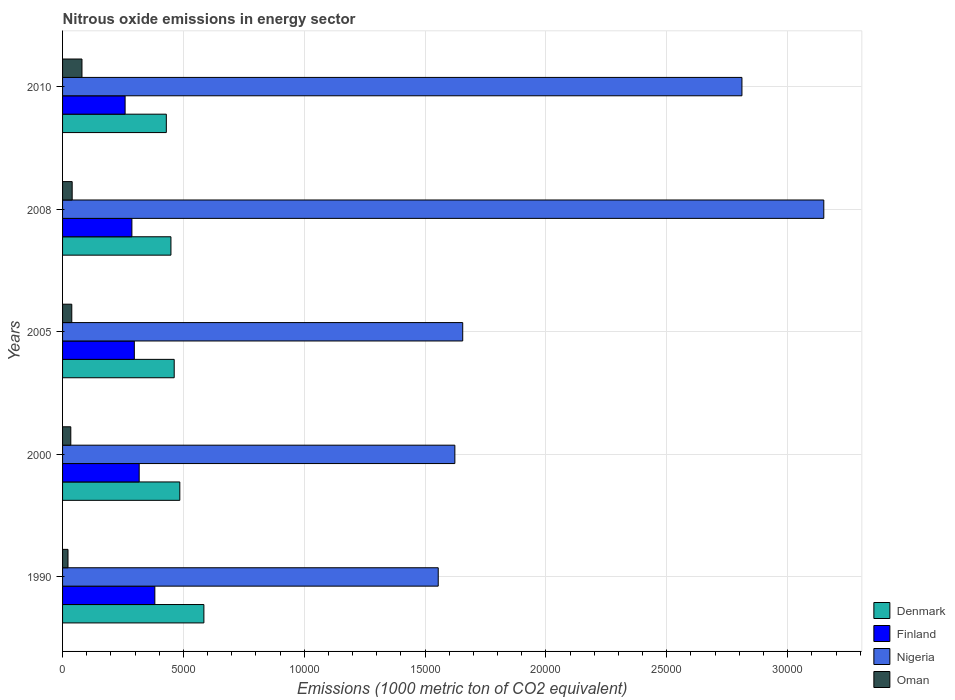How many groups of bars are there?
Keep it short and to the point. 5. Are the number of bars per tick equal to the number of legend labels?
Your answer should be compact. Yes. How many bars are there on the 2nd tick from the top?
Offer a very short reply. 4. In how many cases, is the number of bars for a given year not equal to the number of legend labels?
Your answer should be very brief. 0. What is the amount of nitrous oxide emitted in Denmark in 2000?
Provide a succinct answer. 4850.8. Across all years, what is the maximum amount of nitrous oxide emitted in Finland?
Offer a terse response. 3817.9. Across all years, what is the minimum amount of nitrous oxide emitted in Finland?
Offer a very short reply. 2587.6. In which year was the amount of nitrous oxide emitted in Denmark minimum?
Provide a short and direct response. 2010. What is the total amount of nitrous oxide emitted in Nigeria in the graph?
Ensure brevity in your answer.  1.08e+05. What is the difference between the amount of nitrous oxide emitted in Oman in 2008 and that in 2010?
Your answer should be compact. -405.6. What is the difference between the amount of nitrous oxide emitted in Finland in 2005 and the amount of nitrous oxide emitted in Oman in 2000?
Your answer should be compact. 2628.6. What is the average amount of nitrous oxide emitted in Denmark per year?
Your answer should be very brief. 4818.62. In the year 2008, what is the difference between the amount of nitrous oxide emitted in Denmark and amount of nitrous oxide emitted in Nigeria?
Your response must be concise. -2.70e+04. What is the ratio of the amount of nitrous oxide emitted in Finland in 1990 to that in 2000?
Provide a succinct answer. 1.2. Is the amount of nitrous oxide emitted in Oman in 1990 less than that in 2000?
Your response must be concise. Yes. Is the difference between the amount of nitrous oxide emitted in Denmark in 1990 and 2000 greater than the difference between the amount of nitrous oxide emitted in Nigeria in 1990 and 2000?
Offer a terse response. Yes. What is the difference between the highest and the second highest amount of nitrous oxide emitted in Finland?
Provide a succinct answer. 648. What is the difference between the highest and the lowest amount of nitrous oxide emitted in Finland?
Ensure brevity in your answer.  1230.3. In how many years, is the amount of nitrous oxide emitted in Oman greater than the average amount of nitrous oxide emitted in Oman taken over all years?
Offer a terse response. 1. Is the sum of the amount of nitrous oxide emitted in Oman in 1990 and 2005 greater than the maximum amount of nitrous oxide emitted in Nigeria across all years?
Your answer should be very brief. No. What does the 1st bar from the top in 2005 represents?
Make the answer very short. Oman. What does the 4th bar from the bottom in 2010 represents?
Provide a succinct answer. Oman. How many bars are there?
Ensure brevity in your answer.  20. How many years are there in the graph?
Provide a short and direct response. 5. Does the graph contain grids?
Ensure brevity in your answer.  Yes. How many legend labels are there?
Your answer should be very brief. 4. What is the title of the graph?
Your response must be concise. Nitrous oxide emissions in energy sector. Does "Marshall Islands" appear as one of the legend labels in the graph?
Offer a very short reply. No. What is the label or title of the X-axis?
Your answer should be compact. Emissions (1000 metric ton of CO2 equivalent). What is the Emissions (1000 metric ton of CO2 equivalent) in Denmark in 1990?
Make the answer very short. 5847.4. What is the Emissions (1000 metric ton of CO2 equivalent) of Finland in 1990?
Offer a very short reply. 3817.9. What is the Emissions (1000 metric ton of CO2 equivalent) of Nigeria in 1990?
Provide a short and direct response. 1.55e+04. What is the Emissions (1000 metric ton of CO2 equivalent) of Oman in 1990?
Your answer should be very brief. 225. What is the Emissions (1000 metric ton of CO2 equivalent) of Denmark in 2000?
Your answer should be compact. 4850.8. What is the Emissions (1000 metric ton of CO2 equivalent) in Finland in 2000?
Your answer should be compact. 3169.9. What is the Emissions (1000 metric ton of CO2 equivalent) of Nigeria in 2000?
Your answer should be very brief. 1.62e+04. What is the Emissions (1000 metric ton of CO2 equivalent) of Oman in 2000?
Provide a short and direct response. 340.4. What is the Emissions (1000 metric ton of CO2 equivalent) in Denmark in 2005?
Your response must be concise. 4618.6. What is the Emissions (1000 metric ton of CO2 equivalent) of Finland in 2005?
Offer a terse response. 2969. What is the Emissions (1000 metric ton of CO2 equivalent) of Nigeria in 2005?
Keep it short and to the point. 1.66e+04. What is the Emissions (1000 metric ton of CO2 equivalent) in Oman in 2005?
Your answer should be compact. 381.4. What is the Emissions (1000 metric ton of CO2 equivalent) of Denmark in 2008?
Your response must be concise. 4483.4. What is the Emissions (1000 metric ton of CO2 equivalent) of Finland in 2008?
Offer a very short reply. 2868. What is the Emissions (1000 metric ton of CO2 equivalent) in Nigeria in 2008?
Provide a short and direct response. 3.15e+04. What is the Emissions (1000 metric ton of CO2 equivalent) in Oman in 2008?
Your response must be concise. 397.4. What is the Emissions (1000 metric ton of CO2 equivalent) in Denmark in 2010?
Provide a short and direct response. 4292.9. What is the Emissions (1000 metric ton of CO2 equivalent) of Finland in 2010?
Your answer should be very brief. 2587.6. What is the Emissions (1000 metric ton of CO2 equivalent) in Nigeria in 2010?
Give a very brief answer. 2.81e+04. What is the Emissions (1000 metric ton of CO2 equivalent) in Oman in 2010?
Offer a terse response. 803. Across all years, what is the maximum Emissions (1000 metric ton of CO2 equivalent) of Denmark?
Give a very brief answer. 5847.4. Across all years, what is the maximum Emissions (1000 metric ton of CO2 equivalent) in Finland?
Ensure brevity in your answer.  3817.9. Across all years, what is the maximum Emissions (1000 metric ton of CO2 equivalent) in Nigeria?
Provide a succinct answer. 3.15e+04. Across all years, what is the maximum Emissions (1000 metric ton of CO2 equivalent) in Oman?
Provide a succinct answer. 803. Across all years, what is the minimum Emissions (1000 metric ton of CO2 equivalent) in Denmark?
Your answer should be very brief. 4292.9. Across all years, what is the minimum Emissions (1000 metric ton of CO2 equivalent) of Finland?
Ensure brevity in your answer.  2587.6. Across all years, what is the minimum Emissions (1000 metric ton of CO2 equivalent) in Nigeria?
Offer a terse response. 1.55e+04. Across all years, what is the minimum Emissions (1000 metric ton of CO2 equivalent) of Oman?
Your answer should be very brief. 225. What is the total Emissions (1000 metric ton of CO2 equivalent) of Denmark in the graph?
Provide a short and direct response. 2.41e+04. What is the total Emissions (1000 metric ton of CO2 equivalent) in Finland in the graph?
Make the answer very short. 1.54e+04. What is the total Emissions (1000 metric ton of CO2 equivalent) in Nigeria in the graph?
Provide a succinct answer. 1.08e+05. What is the total Emissions (1000 metric ton of CO2 equivalent) of Oman in the graph?
Keep it short and to the point. 2147.2. What is the difference between the Emissions (1000 metric ton of CO2 equivalent) of Denmark in 1990 and that in 2000?
Your response must be concise. 996.6. What is the difference between the Emissions (1000 metric ton of CO2 equivalent) in Finland in 1990 and that in 2000?
Keep it short and to the point. 648. What is the difference between the Emissions (1000 metric ton of CO2 equivalent) of Nigeria in 1990 and that in 2000?
Keep it short and to the point. -688.1. What is the difference between the Emissions (1000 metric ton of CO2 equivalent) in Oman in 1990 and that in 2000?
Give a very brief answer. -115.4. What is the difference between the Emissions (1000 metric ton of CO2 equivalent) of Denmark in 1990 and that in 2005?
Provide a short and direct response. 1228.8. What is the difference between the Emissions (1000 metric ton of CO2 equivalent) of Finland in 1990 and that in 2005?
Your response must be concise. 848.9. What is the difference between the Emissions (1000 metric ton of CO2 equivalent) in Nigeria in 1990 and that in 2005?
Your response must be concise. -1013. What is the difference between the Emissions (1000 metric ton of CO2 equivalent) of Oman in 1990 and that in 2005?
Ensure brevity in your answer.  -156.4. What is the difference between the Emissions (1000 metric ton of CO2 equivalent) of Denmark in 1990 and that in 2008?
Keep it short and to the point. 1364. What is the difference between the Emissions (1000 metric ton of CO2 equivalent) of Finland in 1990 and that in 2008?
Your response must be concise. 949.9. What is the difference between the Emissions (1000 metric ton of CO2 equivalent) in Nigeria in 1990 and that in 2008?
Ensure brevity in your answer.  -1.60e+04. What is the difference between the Emissions (1000 metric ton of CO2 equivalent) in Oman in 1990 and that in 2008?
Your answer should be very brief. -172.4. What is the difference between the Emissions (1000 metric ton of CO2 equivalent) of Denmark in 1990 and that in 2010?
Offer a very short reply. 1554.5. What is the difference between the Emissions (1000 metric ton of CO2 equivalent) in Finland in 1990 and that in 2010?
Give a very brief answer. 1230.3. What is the difference between the Emissions (1000 metric ton of CO2 equivalent) in Nigeria in 1990 and that in 2010?
Your answer should be compact. -1.26e+04. What is the difference between the Emissions (1000 metric ton of CO2 equivalent) in Oman in 1990 and that in 2010?
Keep it short and to the point. -578. What is the difference between the Emissions (1000 metric ton of CO2 equivalent) in Denmark in 2000 and that in 2005?
Offer a terse response. 232.2. What is the difference between the Emissions (1000 metric ton of CO2 equivalent) of Finland in 2000 and that in 2005?
Provide a short and direct response. 200.9. What is the difference between the Emissions (1000 metric ton of CO2 equivalent) in Nigeria in 2000 and that in 2005?
Your answer should be compact. -324.9. What is the difference between the Emissions (1000 metric ton of CO2 equivalent) of Oman in 2000 and that in 2005?
Offer a very short reply. -41. What is the difference between the Emissions (1000 metric ton of CO2 equivalent) of Denmark in 2000 and that in 2008?
Give a very brief answer. 367.4. What is the difference between the Emissions (1000 metric ton of CO2 equivalent) of Finland in 2000 and that in 2008?
Offer a terse response. 301.9. What is the difference between the Emissions (1000 metric ton of CO2 equivalent) in Nigeria in 2000 and that in 2008?
Your answer should be compact. -1.53e+04. What is the difference between the Emissions (1000 metric ton of CO2 equivalent) in Oman in 2000 and that in 2008?
Offer a very short reply. -57. What is the difference between the Emissions (1000 metric ton of CO2 equivalent) of Denmark in 2000 and that in 2010?
Give a very brief answer. 557.9. What is the difference between the Emissions (1000 metric ton of CO2 equivalent) of Finland in 2000 and that in 2010?
Offer a terse response. 582.3. What is the difference between the Emissions (1000 metric ton of CO2 equivalent) in Nigeria in 2000 and that in 2010?
Offer a terse response. -1.19e+04. What is the difference between the Emissions (1000 metric ton of CO2 equivalent) in Oman in 2000 and that in 2010?
Keep it short and to the point. -462.6. What is the difference between the Emissions (1000 metric ton of CO2 equivalent) of Denmark in 2005 and that in 2008?
Your answer should be very brief. 135.2. What is the difference between the Emissions (1000 metric ton of CO2 equivalent) of Finland in 2005 and that in 2008?
Your response must be concise. 101. What is the difference between the Emissions (1000 metric ton of CO2 equivalent) in Nigeria in 2005 and that in 2008?
Give a very brief answer. -1.49e+04. What is the difference between the Emissions (1000 metric ton of CO2 equivalent) of Oman in 2005 and that in 2008?
Your response must be concise. -16. What is the difference between the Emissions (1000 metric ton of CO2 equivalent) of Denmark in 2005 and that in 2010?
Your answer should be very brief. 325.7. What is the difference between the Emissions (1000 metric ton of CO2 equivalent) in Finland in 2005 and that in 2010?
Make the answer very short. 381.4. What is the difference between the Emissions (1000 metric ton of CO2 equivalent) in Nigeria in 2005 and that in 2010?
Ensure brevity in your answer.  -1.16e+04. What is the difference between the Emissions (1000 metric ton of CO2 equivalent) in Oman in 2005 and that in 2010?
Make the answer very short. -421.6. What is the difference between the Emissions (1000 metric ton of CO2 equivalent) of Denmark in 2008 and that in 2010?
Offer a very short reply. 190.5. What is the difference between the Emissions (1000 metric ton of CO2 equivalent) in Finland in 2008 and that in 2010?
Ensure brevity in your answer.  280.4. What is the difference between the Emissions (1000 metric ton of CO2 equivalent) in Nigeria in 2008 and that in 2010?
Make the answer very short. 3386.7. What is the difference between the Emissions (1000 metric ton of CO2 equivalent) in Oman in 2008 and that in 2010?
Your answer should be very brief. -405.6. What is the difference between the Emissions (1000 metric ton of CO2 equivalent) in Denmark in 1990 and the Emissions (1000 metric ton of CO2 equivalent) in Finland in 2000?
Offer a very short reply. 2677.5. What is the difference between the Emissions (1000 metric ton of CO2 equivalent) of Denmark in 1990 and the Emissions (1000 metric ton of CO2 equivalent) of Nigeria in 2000?
Make the answer very short. -1.04e+04. What is the difference between the Emissions (1000 metric ton of CO2 equivalent) in Denmark in 1990 and the Emissions (1000 metric ton of CO2 equivalent) in Oman in 2000?
Ensure brevity in your answer.  5507. What is the difference between the Emissions (1000 metric ton of CO2 equivalent) in Finland in 1990 and the Emissions (1000 metric ton of CO2 equivalent) in Nigeria in 2000?
Provide a succinct answer. -1.24e+04. What is the difference between the Emissions (1000 metric ton of CO2 equivalent) of Finland in 1990 and the Emissions (1000 metric ton of CO2 equivalent) of Oman in 2000?
Your answer should be very brief. 3477.5. What is the difference between the Emissions (1000 metric ton of CO2 equivalent) of Nigeria in 1990 and the Emissions (1000 metric ton of CO2 equivalent) of Oman in 2000?
Give a very brief answer. 1.52e+04. What is the difference between the Emissions (1000 metric ton of CO2 equivalent) in Denmark in 1990 and the Emissions (1000 metric ton of CO2 equivalent) in Finland in 2005?
Make the answer very short. 2878.4. What is the difference between the Emissions (1000 metric ton of CO2 equivalent) of Denmark in 1990 and the Emissions (1000 metric ton of CO2 equivalent) of Nigeria in 2005?
Make the answer very short. -1.07e+04. What is the difference between the Emissions (1000 metric ton of CO2 equivalent) in Denmark in 1990 and the Emissions (1000 metric ton of CO2 equivalent) in Oman in 2005?
Provide a short and direct response. 5466. What is the difference between the Emissions (1000 metric ton of CO2 equivalent) of Finland in 1990 and the Emissions (1000 metric ton of CO2 equivalent) of Nigeria in 2005?
Give a very brief answer. -1.27e+04. What is the difference between the Emissions (1000 metric ton of CO2 equivalent) of Finland in 1990 and the Emissions (1000 metric ton of CO2 equivalent) of Oman in 2005?
Provide a succinct answer. 3436.5. What is the difference between the Emissions (1000 metric ton of CO2 equivalent) in Nigeria in 1990 and the Emissions (1000 metric ton of CO2 equivalent) in Oman in 2005?
Offer a very short reply. 1.52e+04. What is the difference between the Emissions (1000 metric ton of CO2 equivalent) of Denmark in 1990 and the Emissions (1000 metric ton of CO2 equivalent) of Finland in 2008?
Ensure brevity in your answer.  2979.4. What is the difference between the Emissions (1000 metric ton of CO2 equivalent) of Denmark in 1990 and the Emissions (1000 metric ton of CO2 equivalent) of Nigeria in 2008?
Your response must be concise. -2.56e+04. What is the difference between the Emissions (1000 metric ton of CO2 equivalent) of Denmark in 1990 and the Emissions (1000 metric ton of CO2 equivalent) of Oman in 2008?
Make the answer very short. 5450. What is the difference between the Emissions (1000 metric ton of CO2 equivalent) of Finland in 1990 and the Emissions (1000 metric ton of CO2 equivalent) of Nigeria in 2008?
Offer a very short reply. -2.77e+04. What is the difference between the Emissions (1000 metric ton of CO2 equivalent) of Finland in 1990 and the Emissions (1000 metric ton of CO2 equivalent) of Oman in 2008?
Provide a succinct answer. 3420.5. What is the difference between the Emissions (1000 metric ton of CO2 equivalent) in Nigeria in 1990 and the Emissions (1000 metric ton of CO2 equivalent) in Oman in 2008?
Your response must be concise. 1.51e+04. What is the difference between the Emissions (1000 metric ton of CO2 equivalent) of Denmark in 1990 and the Emissions (1000 metric ton of CO2 equivalent) of Finland in 2010?
Your answer should be very brief. 3259.8. What is the difference between the Emissions (1000 metric ton of CO2 equivalent) of Denmark in 1990 and the Emissions (1000 metric ton of CO2 equivalent) of Nigeria in 2010?
Your answer should be very brief. -2.23e+04. What is the difference between the Emissions (1000 metric ton of CO2 equivalent) of Denmark in 1990 and the Emissions (1000 metric ton of CO2 equivalent) of Oman in 2010?
Ensure brevity in your answer.  5044.4. What is the difference between the Emissions (1000 metric ton of CO2 equivalent) of Finland in 1990 and the Emissions (1000 metric ton of CO2 equivalent) of Nigeria in 2010?
Offer a terse response. -2.43e+04. What is the difference between the Emissions (1000 metric ton of CO2 equivalent) of Finland in 1990 and the Emissions (1000 metric ton of CO2 equivalent) of Oman in 2010?
Your answer should be very brief. 3014.9. What is the difference between the Emissions (1000 metric ton of CO2 equivalent) in Nigeria in 1990 and the Emissions (1000 metric ton of CO2 equivalent) in Oman in 2010?
Provide a short and direct response. 1.47e+04. What is the difference between the Emissions (1000 metric ton of CO2 equivalent) in Denmark in 2000 and the Emissions (1000 metric ton of CO2 equivalent) in Finland in 2005?
Ensure brevity in your answer.  1881.8. What is the difference between the Emissions (1000 metric ton of CO2 equivalent) in Denmark in 2000 and the Emissions (1000 metric ton of CO2 equivalent) in Nigeria in 2005?
Ensure brevity in your answer.  -1.17e+04. What is the difference between the Emissions (1000 metric ton of CO2 equivalent) in Denmark in 2000 and the Emissions (1000 metric ton of CO2 equivalent) in Oman in 2005?
Offer a terse response. 4469.4. What is the difference between the Emissions (1000 metric ton of CO2 equivalent) of Finland in 2000 and the Emissions (1000 metric ton of CO2 equivalent) of Nigeria in 2005?
Your response must be concise. -1.34e+04. What is the difference between the Emissions (1000 metric ton of CO2 equivalent) in Finland in 2000 and the Emissions (1000 metric ton of CO2 equivalent) in Oman in 2005?
Your answer should be very brief. 2788.5. What is the difference between the Emissions (1000 metric ton of CO2 equivalent) of Nigeria in 2000 and the Emissions (1000 metric ton of CO2 equivalent) of Oman in 2005?
Ensure brevity in your answer.  1.58e+04. What is the difference between the Emissions (1000 metric ton of CO2 equivalent) of Denmark in 2000 and the Emissions (1000 metric ton of CO2 equivalent) of Finland in 2008?
Offer a terse response. 1982.8. What is the difference between the Emissions (1000 metric ton of CO2 equivalent) of Denmark in 2000 and the Emissions (1000 metric ton of CO2 equivalent) of Nigeria in 2008?
Offer a terse response. -2.66e+04. What is the difference between the Emissions (1000 metric ton of CO2 equivalent) of Denmark in 2000 and the Emissions (1000 metric ton of CO2 equivalent) of Oman in 2008?
Keep it short and to the point. 4453.4. What is the difference between the Emissions (1000 metric ton of CO2 equivalent) of Finland in 2000 and the Emissions (1000 metric ton of CO2 equivalent) of Nigeria in 2008?
Make the answer very short. -2.83e+04. What is the difference between the Emissions (1000 metric ton of CO2 equivalent) of Finland in 2000 and the Emissions (1000 metric ton of CO2 equivalent) of Oman in 2008?
Offer a terse response. 2772.5. What is the difference between the Emissions (1000 metric ton of CO2 equivalent) of Nigeria in 2000 and the Emissions (1000 metric ton of CO2 equivalent) of Oman in 2008?
Your response must be concise. 1.58e+04. What is the difference between the Emissions (1000 metric ton of CO2 equivalent) of Denmark in 2000 and the Emissions (1000 metric ton of CO2 equivalent) of Finland in 2010?
Make the answer very short. 2263.2. What is the difference between the Emissions (1000 metric ton of CO2 equivalent) of Denmark in 2000 and the Emissions (1000 metric ton of CO2 equivalent) of Nigeria in 2010?
Make the answer very short. -2.33e+04. What is the difference between the Emissions (1000 metric ton of CO2 equivalent) of Denmark in 2000 and the Emissions (1000 metric ton of CO2 equivalent) of Oman in 2010?
Your response must be concise. 4047.8. What is the difference between the Emissions (1000 metric ton of CO2 equivalent) in Finland in 2000 and the Emissions (1000 metric ton of CO2 equivalent) in Nigeria in 2010?
Offer a terse response. -2.49e+04. What is the difference between the Emissions (1000 metric ton of CO2 equivalent) in Finland in 2000 and the Emissions (1000 metric ton of CO2 equivalent) in Oman in 2010?
Make the answer very short. 2366.9. What is the difference between the Emissions (1000 metric ton of CO2 equivalent) of Nigeria in 2000 and the Emissions (1000 metric ton of CO2 equivalent) of Oman in 2010?
Give a very brief answer. 1.54e+04. What is the difference between the Emissions (1000 metric ton of CO2 equivalent) in Denmark in 2005 and the Emissions (1000 metric ton of CO2 equivalent) in Finland in 2008?
Provide a short and direct response. 1750.6. What is the difference between the Emissions (1000 metric ton of CO2 equivalent) of Denmark in 2005 and the Emissions (1000 metric ton of CO2 equivalent) of Nigeria in 2008?
Provide a succinct answer. -2.69e+04. What is the difference between the Emissions (1000 metric ton of CO2 equivalent) of Denmark in 2005 and the Emissions (1000 metric ton of CO2 equivalent) of Oman in 2008?
Your response must be concise. 4221.2. What is the difference between the Emissions (1000 metric ton of CO2 equivalent) in Finland in 2005 and the Emissions (1000 metric ton of CO2 equivalent) in Nigeria in 2008?
Your response must be concise. -2.85e+04. What is the difference between the Emissions (1000 metric ton of CO2 equivalent) of Finland in 2005 and the Emissions (1000 metric ton of CO2 equivalent) of Oman in 2008?
Keep it short and to the point. 2571.6. What is the difference between the Emissions (1000 metric ton of CO2 equivalent) in Nigeria in 2005 and the Emissions (1000 metric ton of CO2 equivalent) in Oman in 2008?
Make the answer very short. 1.62e+04. What is the difference between the Emissions (1000 metric ton of CO2 equivalent) of Denmark in 2005 and the Emissions (1000 metric ton of CO2 equivalent) of Finland in 2010?
Ensure brevity in your answer.  2031. What is the difference between the Emissions (1000 metric ton of CO2 equivalent) of Denmark in 2005 and the Emissions (1000 metric ton of CO2 equivalent) of Nigeria in 2010?
Offer a very short reply. -2.35e+04. What is the difference between the Emissions (1000 metric ton of CO2 equivalent) in Denmark in 2005 and the Emissions (1000 metric ton of CO2 equivalent) in Oman in 2010?
Provide a succinct answer. 3815.6. What is the difference between the Emissions (1000 metric ton of CO2 equivalent) in Finland in 2005 and the Emissions (1000 metric ton of CO2 equivalent) in Nigeria in 2010?
Provide a short and direct response. -2.51e+04. What is the difference between the Emissions (1000 metric ton of CO2 equivalent) of Finland in 2005 and the Emissions (1000 metric ton of CO2 equivalent) of Oman in 2010?
Offer a very short reply. 2166. What is the difference between the Emissions (1000 metric ton of CO2 equivalent) in Nigeria in 2005 and the Emissions (1000 metric ton of CO2 equivalent) in Oman in 2010?
Give a very brief answer. 1.58e+04. What is the difference between the Emissions (1000 metric ton of CO2 equivalent) in Denmark in 2008 and the Emissions (1000 metric ton of CO2 equivalent) in Finland in 2010?
Keep it short and to the point. 1895.8. What is the difference between the Emissions (1000 metric ton of CO2 equivalent) of Denmark in 2008 and the Emissions (1000 metric ton of CO2 equivalent) of Nigeria in 2010?
Your answer should be very brief. -2.36e+04. What is the difference between the Emissions (1000 metric ton of CO2 equivalent) in Denmark in 2008 and the Emissions (1000 metric ton of CO2 equivalent) in Oman in 2010?
Give a very brief answer. 3680.4. What is the difference between the Emissions (1000 metric ton of CO2 equivalent) in Finland in 2008 and the Emissions (1000 metric ton of CO2 equivalent) in Nigeria in 2010?
Offer a terse response. -2.52e+04. What is the difference between the Emissions (1000 metric ton of CO2 equivalent) of Finland in 2008 and the Emissions (1000 metric ton of CO2 equivalent) of Oman in 2010?
Offer a terse response. 2065. What is the difference between the Emissions (1000 metric ton of CO2 equivalent) in Nigeria in 2008 and the Emissions (1000 metric ton of CO2 equivalent) in Oman in 2010?
Make the answer very short. 3.07e+04. What is the average Emissions (1000 metric ton of CO2 equivalent) of Denmark per year?
Make the answer very short. 4818.62. What is the average Emissions (1000 metric ton of CO2 equivalent) in Finland per year?
Your answer should be compact. 3082.48. What is the average Emissions (1000 metric ton of CO2 equivalent) of Nigeria per year?
Your answer should be very brief. 2.16e+04. What is the average Emissions (1000 metric ton of CO2 equivalent) in Oman per year?
Your answer should be very brief. 429.44. In the year 1990, what is the difference between the Emissions (1000 metric ton of CO2 equivalent) of Denmark and Emissions (1000 metric ton of CO2 equivalent) of Finland?
Give a very brief answer. 2029.5. In the year 1990, what is the difference between the Emissions (1000 metric ton of CO2 equivalent) in Denmark and Emissions (1000 metric ton of CO2 equivalent) in Nigeria?
Provide a succinct answer. -9695.1. In the year 1990, what is the difference between the Emissions (1000 metric ton of CO2 equivalent) in Denmark and Emissions (1000 metric ton of CO2 equivalent) in Oman?
Your answer should be very brief. 5622.4. In the year 1990, what is the difference between the Emissions (1000 metric ton of CO2 equivalent) in Finland and Emissions (1000 metric ton of CO2 equivalent) in Nigeria?
Keep it short and to the point. -1.17e+04. In the year 1990, what is the difference between the Emissions (1000 metric ton of CO2 equivalent) in Finland and Emissions (1000 metric ton of CO2 equivalent) in Oman?
Your answer should be very brief. 3592.9. In the year 1990, what is the difference between the Emissions (1000 metric ton of CO2 equivalent) of Nigeria and Emissions (1000 metric ton of CO2 equivalent) of Oman?
Your answer should be compact. 1.53e+04. In the year 2000, what is the difference between the Emissions (1000 metric ton of CO2 equivalent) in Denmark and Emissions (1000 metric ton of CO2 equivalent) in Finland?
Offer a very short reply. 1680.9. In the year 2000, what is the difference between the Emissions (1000 metric ton of CO2 equivalent) in Denmark and Emissions (1000 metric ton of CO2 equivalent) in Nigeria?
Ensure brevity in your answer.  -1.14e+04. In the year 2000, what is the difference between the Emissions (1000 metric ton of CO2 equivalent) of Denmark and Emissions (1000 metric ton of CO2 equivalent) of Oman?
Make the answer very short. 4510.4. In the year 2000, what is the difference between the Emissions (1000 metric ton of CO2 equivalent) in Finland and Emissions (1000 metric ton of CO2 equivalent) in Nigeria?
Ensure brevity in your answer.  -1.31e+04. In the year 2000, what is the difference between the Emissions (1000 metric ton of CO2 equivalent) in Finland and Emissions (1000 metric ton of CO2 equivalent) in Oman?
Ensure brevity in your answer.  2829.5. In the year 2000, what is the difference between the Emissions (1000 metric ton of CO2 equivalent) of Nigeria and Emissions (1000 metric ton of CO2 equivalent) of Oman?
Ensure brevity in your answer.  1.59e+04. In the year 2005, what is the difference between the Emissions (1000 metric ton of CO2 equivalent) in Denmark and Emissions (1000 metric ton of CO2 equivalent) in Finland?
Provide a succinct answer. 1649.6. In the year 2005, what is the difference between the Emissions (1000 metric ton of CO2 equivalent) in Denmark and Emissions (1000 metric ton of CO2 equivalent) in Nigeria?
Keep it short and to the point. -1.19e+04. In the year 2005, what is the difference between the Emissions (1000 metric ton of CO2 equivalent) of Denmark and Emissions (1000 metric ton of CO2 equivalent) of Oman?
Provide a succinct answer. 4237.2. In the year 2005, what is the difference between the Emissions (1000 metric ton of CO2 equivalent) in Finland and Emissions (1000 metric ton of CO2 equivalent) in Nigeria?
Give a very brief answer. -1.36e+04. In the year 2005, what is the difference between the Emissions (1000 metric ton of CO2 equivalent) of Finland and Emissions (1000 metric ton of CO2 equivalent) of Oman?
Your response must be concise. 2587.6. In the year 2005, what is the difference between the Emissions (1000 metric ton of CO2 equivalent) in Nigeria and Emissions (1000 metric ton of CO2 equivalent) in Oman?
Offer a very short reply. 1.62e+04. In the year 2008, what is the difference between the Emissions (1000 metric ton of CO2 equivalent) in Denmark and Emissions (1000 metric ton of CO2 equivalent) in Finland?
Provide a short and direct response. 1615.4. In the year 2008, what is the difference between the Emissions (1000 metric ton of CO2 equivalent) of Denmark and Emissions (1000 metric ton of CO2 equivalent) of Nigeria?
Offer a very short reply. -2.70e+04. In the year 2008, what is the difference between the Emissions (1000 metric ton of CO2 equivalent) in Denmark and Emissions (1000 metric ton of CO2 equivalent) in Oman?
Provide a succinct answer. 4086. In the year 2008, what is the difference between the Emissions (1000 metric ton of CO2 equivalent) of Finland and Emissions (1000 metric ton of CO2 equivalent) of Nigeria?
Offer a terse response. -2.86e+04. In the year 2008, what is the difference between the Emissions (1000 metric ton of CO2 equivalent) in Finland and Emissions (1000 metric ton of CO2 equivalent) in Oman?
Offer a terse response. 2470.6. In the year 2008, what is the difference between the Emissions (1000 metric ton of CO2 equivalent) in Nigeria and Emissions (1000 metric ton of CO2 equivalent) in Oman?
Your answer should be compact. 3.11e+04. In the year 2010, what is the difference between the Emissions (1000 metric ton of CO2 equivalent) of Denmark and Emissions (1000 metric ton of CO2 equivalent) of Finland?
Provide a succinct answer. 1705.3. In the year 2010, what is the difference between the Emissions (1000 metric ton of CO2 equivalent) of Denmark and Emissions (1000 metric ton of CO2 equivalent) of Nigeria?
Your answer should be very brief. -2.38e+04. In the year 2010, what is the difference between the Emissions (1000 metric ton of CO2 equivalent) of Denmark and Emissions (1000 metric ton of CO2 equivalent) of Oman?
Your response must be concise. 3489.9. In the year 2010, what is the difference between the Emissions (1000 metric ton of CO2 equivalent) of Finland and Emissions (1000 metric ton of CO2 equivalent) of Nigeria?
Make the answer very short. -2.55e+04. In the year 2010, what is the difference between the Emissions (1000 metric ton of CO2 equivalent) of Finland and Emissions (1000 metric ton of CO2 equivalent) of Oman?
Give a very brief answer. 1784.6. In the year 2010, what is the difference between the Emissions (1000 metric ton of CO2 equivalent) in Nigeria and Emissions (1000 metric ton of CO2 equivalent) in Oman?
Provide a succinct answer. 2.73e+04. What is the ratio of the Emissions (1000 metric ton of CO2 equivalent) in Denmark in 1990 to that in 2000?
Give a very brief answer. 1.21. What is the ratio of the Emissions (1000 metric ton of CO2 equivalent) of Finland in 1990 to that in 2000?
Offer a terse response. 1.2. What is the ratio of the Emissions (1000 metric ton of CO2 equivalent) in Nigeria in 1990 to that in 2000?
Your answer should be very brief. 0.96. What is the ratio of the Emissions (1000 metric ton of CO2 equivalent) in Oman in 1990 to that in 2000?
Make the answer very short. 0.66. What is the ratio of the Emissions (1000 metric ton of CO2 equivalent) in Denmark in 1990 to that in 2005?
Offer a very short reply. 1.27. What is the ratio of the Emissions (1000 metric ton of CO2 equivalent) in Finland in 1990 to that in 2005?
Keep it short and to the point. 1.29. What is the ratio of the Emissions (1000 metric ton of CO2 equivalent) in Nigeria in 1990 to that in 2005?
Offer a very short reply. 0.94. What is the ratio of the Emissions (1000 metric ton of CO2 equivalent) in Oman in 1990 to that in 2005?
Ensure brevity in your answer.  0.59. What is the ratio of the Emissions (1000 metric ton of CO2 equivalent) of Denmark in 1990 to that in 2008?
Make the answer very short. 1.3. What is the ratio of the Emissions (1000 metric ton of CO2 equivalent) in Finland in 1990 to that in 2008?
Your response must be concise. 1.33. What is the ratio of the Emissions (1000 metric ton of CO2 equivalent) of Nigeria in 1990 to that in 2008?
Make the answer very short. 0.49. What is the ratio of the Emissions (1000 metric ton of CO2 equivalent) of Oman in 1990 to that in 2008?
Your answer should be compact. 0.57. What is the ratio of the Emissions (1000 metric ton of CO2 equivalent) of Denmark in 1990 to that in 2010?
Offer a terse response. 1.36. What is the ratio of the Emissions (1000 metric ton of CO2 equivalent) in Finland in 1990 to that in 2010?
Your response must be concise. 1.48. What is the ratio of the Emissions (1000 metric ton of CO2 equivalent) of Nigeria in 1990 to that in 2010?
Your response must be concise. 0.55. What is the ratio of the Emissions (1000 metric ton of CO2 equivalent) of Oman in 1990 to that in 2010?
Offer a very short reply. 0.28. What is the ratio of the Emissions (1000 metric ton of CO2 equivalent) in Denmark in 2000 to that in 2005?
Your answer should be very brief. 1.05. What is the ratio of the Emissions (1000 metric ton of CO2 equivalent) in Finland in 2000 to that in 2005?
Offer a terse response. 1.07. What is the ratio of the Emissions (1000 metric ton of CO2 equivalent) in Nigeria in 2000 to that in 2005?
Your response must be concise. 0.98. What is the ratio of the Emissions (1000 metric ton of CO2 equivalent) in Oman in 2000 to that in 2005?
Offer a terse response. 0.89. What is the ratio of the Emissions (1000 metric ton of CO2 equivalent) in Denmark in 2000 to that in 2008?
Your answer should be compact. 1.08. What is the ratio of the Emissions (1000 metric ton of CO2 equivalent) in Finland in 2000 to that in 2008?
Your response must be concise. 1.11. What is the ratio of the Emissions (1000 metric ton of CO2 equivalent) of Nigeria in 2000 to that in 2008?
Ensure brevity in your answer.  0.52. What is the ratio of the Emissions (1000 metric ton of CO2 equivalent) in Oman in 2000 to that in 2008?
Your answer should be very brief. 0.86. What is the ratio of the Emissions (1000 metric ton of CO2 equivalent) in Denmark in 2000 to that in 2010?
Your answer should be very brief. 1.13. What is the ratio of the Emissions (1000 metric ton of CO2 equivalent) in Finland in 2000 to that in 2010?
Ensure brevity in your answer.  1.23. What is the ratio of the Emissions (1000 metric ton of CO2 equivalent) in Nigeria in 2000 to that in 2010?
Your answer should be very brief. 0.58. What is the ratio of the Emissions (1000 metric ton of CO2 equivalent) in Oman in 2000 to that in 2010?
Offer a very short reply. 0.42. What is the ratio of the Emissions (1000 metric ton of CO2 equivalent) in Denmark in 2005 to that in 2008?
Offer a very short reply. 1.03. What is the ratio of the Emissions (1000 metric ton of CO2 equivalent) in Finland in 2005 to that in 2008?
Your answer should be very brief. 1.04. What is the ratio of the Emissions (1000 metric ton of CO2 equivalent) of Nigeria in 2005 to that in 2008?
Your response must be concise. 0.53. What is the ratio of the Emissions (1000 metric ton of CO2 equivalent) in Oman in 2005 to that in 2008?
Your answer should be very brief. 0.96. What is the ratio of the Emissions (1000 metric ton of CO2 equivalent) of Denmark in 2005 to that in 2010?
Make the answer very short. 1.08. What is the ratio of the Emissions (1000 metric ton of CO2 equivalent) in Finland in 2005 to that in 2010?
Your response must be concise. 1.15. What is the ratio of the Emissions (1000 metric ton of CO2 equivalent) in Nigeria in 2005 to that in 2010?
Provide a short and direct response. 0.59. What is the ratio of the Emissions (1000 metric ton of CO2 equivalent) in Oman in 2005 to that in 2010?
Your response must be concise. 0.47. What is the ratio of the Emissions (1000 metric ton of CO2 equivalent) in Denmark in 2008 to that in 2010?
Offer a very short reply. 1.04. What is the ratio of the Emissions (1000 metric ton of CO2 equivalent) of Finland in 2008 to that in 2010?
Give a very brief answer. 1.11. What is the ratio of the Emissions (1000 metric ton of CO2 equivalent) in Nigeria in 2008 to that in 2010?
Provide a short and direct response. 1.12. What is the ratio of the Emissions (1000 metric ton of CO2 equivalent) of Oman in 2008 to that in 2010?
Offer a very short reply. 0.49. What is the difference between the highest and the second highest Emissions (1000 metric ton of CO2 equivalent) in Denmark?
Keep it short and to the point. 996.6. What is the difference between the highest and the second highest Emissions (1000 metric ton of CO2 equivalent) in Finland?
Offer a terse response. 648. What is the difference between the highest and the second highest Emissions (1000 metric ton of CO2 equivalent) in Nigeria?
Give a very brief answer. 3386.7. What is the difference between the highest and the second highest Emissions (1000 metric ton of CO2 equivalent) in Oman?
Offer a very short reply. 405.6. What is the difference between the highest and the lowest Emissions (1000 metric ton of CO2 equivalent) in Denmark?
Keep it short and to the point. 1554.5. What is the difference between the highest and the lowest Emissions (1000 metric ton of CO2 equivalent) in Finland?
Offer a very short reply. 1230.3. What is the difference between the highest and the lowest Emissions (1000 metric ton of CO2 equivalent) in Nigeria?
Keep it short and to the point. 1.60e+04. What is the difference between the highest and the lowest Emissions (1000 metric ton of CO2 equivalent) in Oman?
Your response must be concise. 578. 